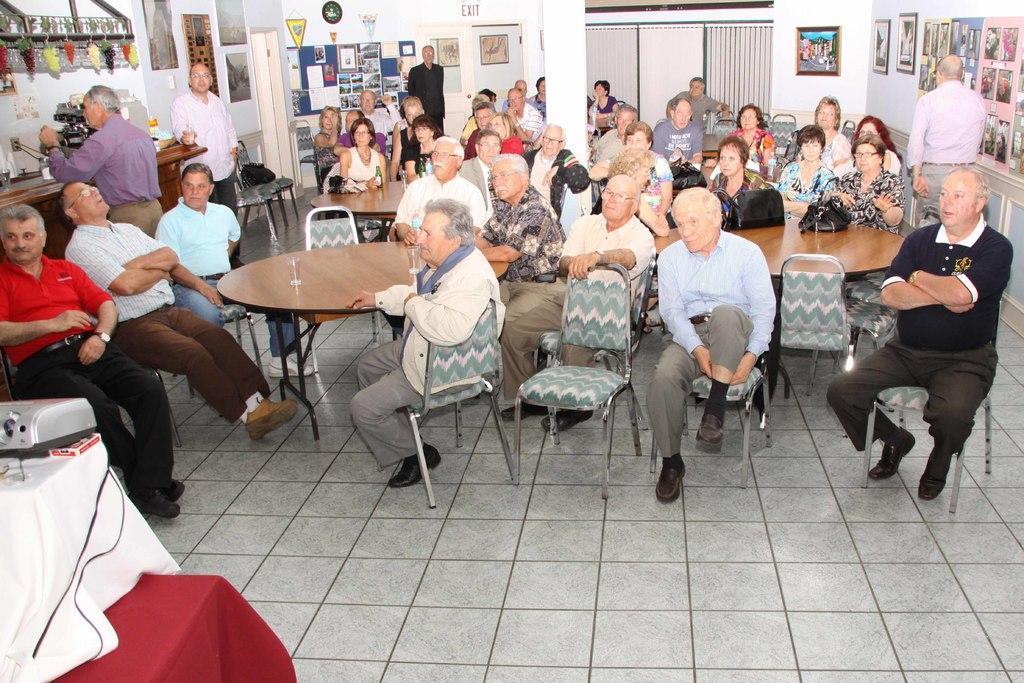Could you give a brief overview of what you see in this image? This picture is clicked inside the room. There are many people sitting on chair around the table. Here, we see a table on which two gases are placed and on the left bottom of the picture, we see a table with red cloth on it and above it, we see another table with white cloth on it and on the table, we see projector. On the left top of the picture, we see grapes hanged and beside that, we see a wall with many photo frames and beside that, we see watch and behind these people, we see curtains which are white in color. 